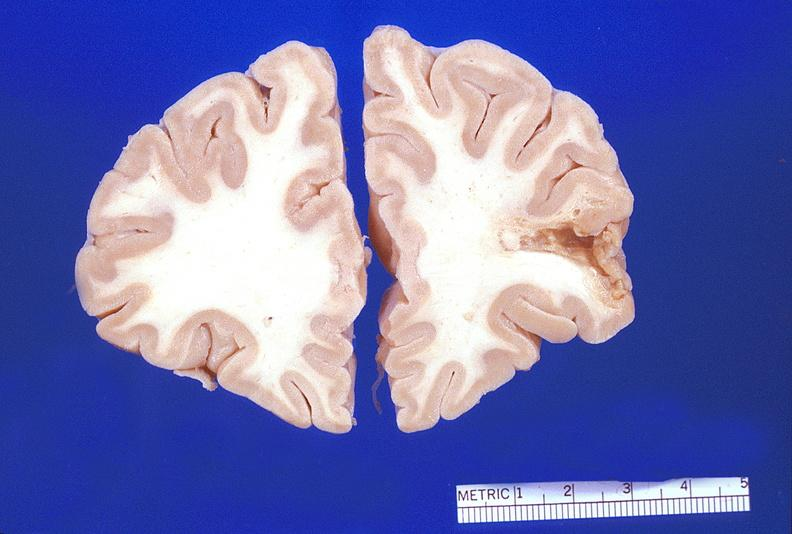what does this image show?
Answer the question using a single word or phrase. Brain 